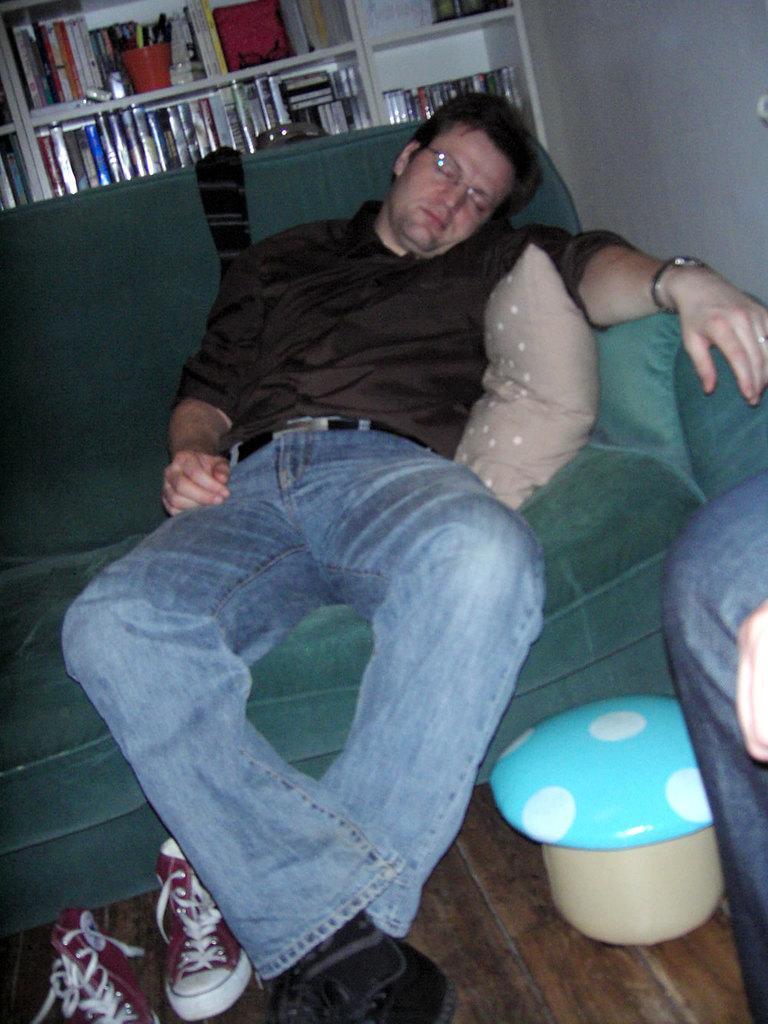Describe this image in one or two sentences. The picture is taken in a room. In the center there is a person sleeping on the couch. In the foreground there are shoes, stool and a person's leg. In the background there are books and pens in the shelf. 